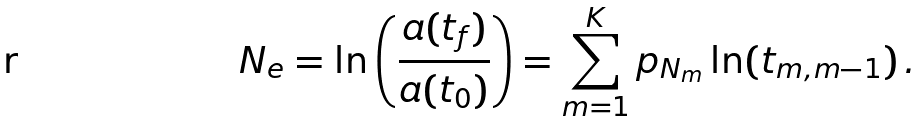<formula> <loc_0><loc_0><loc_500><loc_500>N _ { e } = \ln \left ( \frac { a ( t _ { f } ) } { a ( t _ { 0 } ) } \right ) = \sum _ { m = 1 } ^ { K } p _ { N _ { m } } \ln ( t _ { m , m - 1 } ) \, .</formula> 